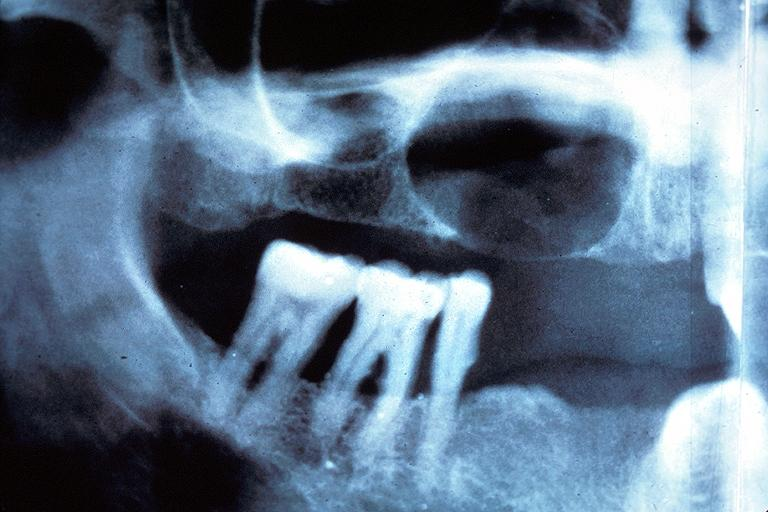does lymphangiomatosis generalized show residual cyst?
Answer the question using a single word or phrase. No 